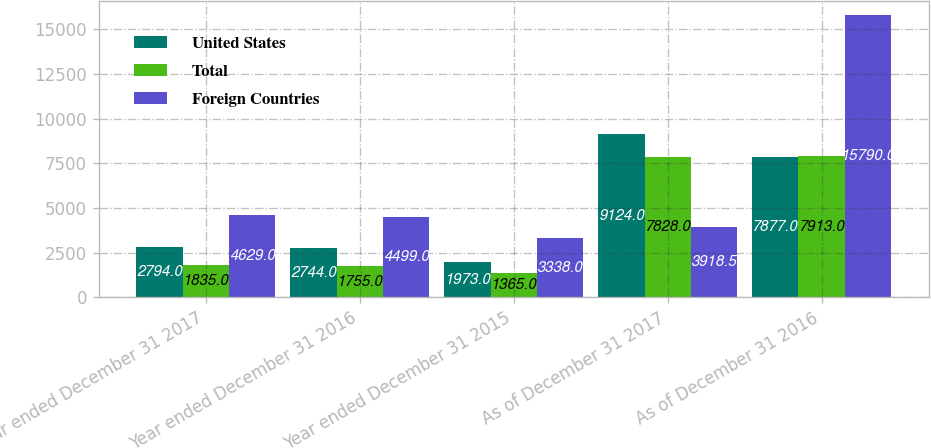<chart> <loc_0><loc_0><loc_500><loc_500><stacked_bar_chart><ecel><fcel>Year ended December 31 2017<fcel>Year ended December 31 2016<fcel>Year ended December 31 2015<fcel>As of December 31 2017<fcel>As of December 31 2016<nl><fcel>United States<fcel>2794<fcel>2744<fcel>1973<fcel>9124<fcel>7877<nl><fcel>Total<fcel>1835<fcel>1755<fcel>1365<fcel>7828<fcel>7913<nl><fcel>Foreign Countries<fcel>4629<fcel>4499<fcel>3338<fcel>3918.5<fcel>15790<nl></chart> 